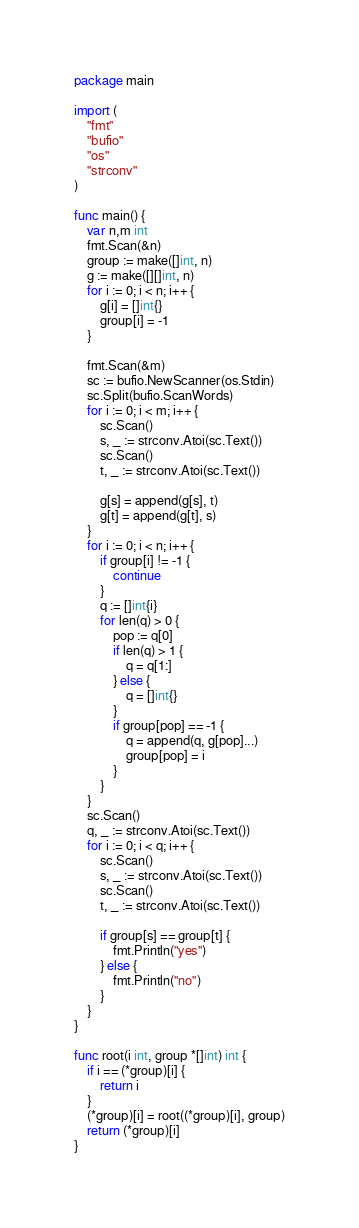<code> <loc_0><loc_0><loc_500><loc_500><_Go_>package main

import (
	"fmt"
	"bufio"
	"os"
	"strconv"
)

func main() {
	var n,m int
	fmt.Scan(&n)
	group := make([]int, n)
	g := make([][]int, n)
	for i := 0; i < n; i++ {
		g[i] = []int{}
		group[i] = -1
	}
	
	fmt.Scan(&m)
	sc := bufio.NewScanner(os.Stdin)
	sc.Split(bufio.ScanWords)
	for i := 0; i < m; i++ {
		sc.Scan()
		s, _ := strconv.Atoi(sc.Text())
		sc.Scan()
		t, _ := strconv.Atoi(sc.Text())
		
		g[s] = append(g[s], t)
		g[t] = append(g[t], s)
	}
	for i := 0; i < n; i++ {
		if group[i] != -1 {
			continue
		}
		q := []int{i}
		for len(q) > 0 {
			pop := q[0]
			if len(q) > 1 {
				q = q[1:]
			} else {
				q = []int{}
			}
			if group[pop] == -1 {
				q = append(q, g[pop]...)
				group[pop] = i
			}
		}
	}
	sc.Scan()
	q, _ := strconv.Atoi(sc.Text())
	for i := 0; i < q; i++ {
		sc.Scan()
		s, _ := strconv.Atoi(sc.Text())
		sc.Scan()
		t, _ := strconv.Atoi(sc.Text())

		if group[s] == group[t] {
			fmt.Println("yes")
		} else {
			fmt.Println("no")
		}
	}
}

func root(i int, group *[]int) int {
	if i == (*group)[i] {
		return i
	}
	(*group)[i] = root((*group)[i], group)
	return (*group)[i]
}

</code> 